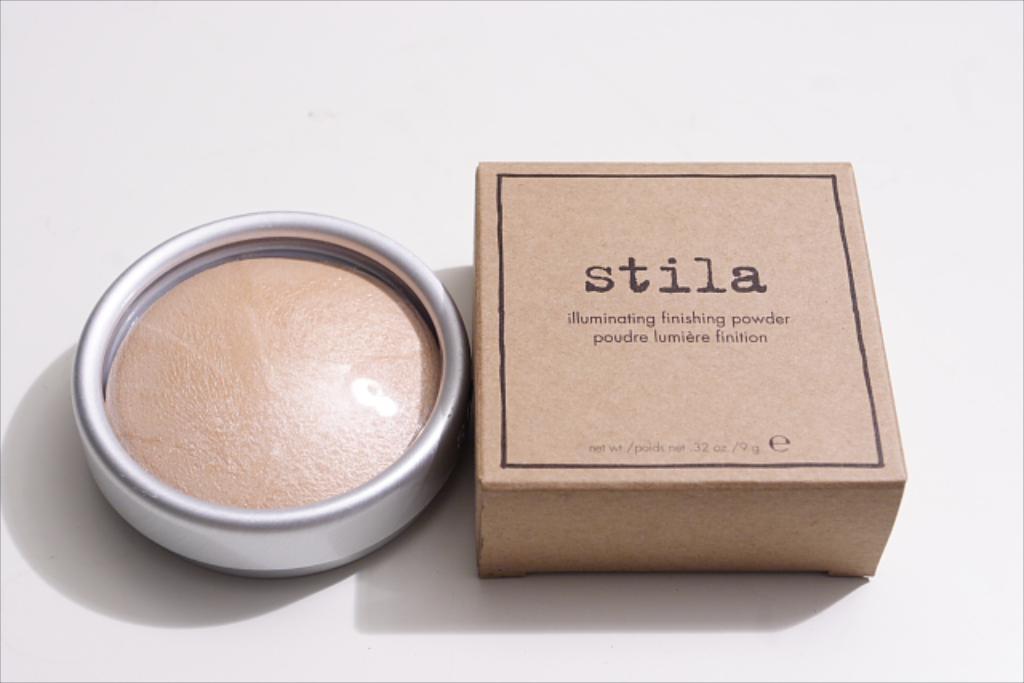Who made this product?
Provide a succinct answer. Stila. What kind of powder is this?
Offer a terse response. Finishing powder. 